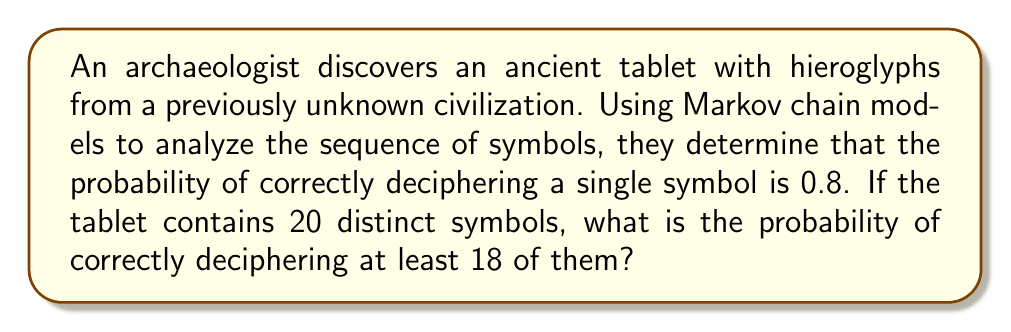Solve this math problem. Let's approach this step-by-step:

1) This problem follows a binomial distribution, where:
   n = 20 (total number of symbols)
   p = 0.8 (probability of success for each symbol)
   We want to find P(X ≥ 18), where X is the number of correctly deciphered symbols.

2) We can calculate this as:
   P(X ≥ 18) = P(X = 18) + P(X = 19) + P(X = 20)

3) The probability mass function for a binomial distribution is:
   $$P(X = k) = \binom{n}{k} p^k (1-p)^{n-k}$$

4) Let's calculate each probability:

   For k = 18:
   $$P(X = 18) = \binom{20}{18} (0.8)^{18} (0.2)^2 = 190 \cdot 0.8^{18} \cdot 0.2^2 = 0.2759$$

   For k = 19:
   $$P(X = 19) = \binom{20}{19} (0.8)^{19} (0.2)^1 = 20 \cdot 0.8^{19} \cdot 0.2 = 0.3932$$

   For k = 20:
   $$P(X = 20) = \binom{20}{20} (0.8)^{20} (0.2)^0 = 1 \cdot 0.8^{20} = 0.1152$$

5) Sum these probabilities:
   P(X ≥ 18) = 0.2759 + 0.3932 + 0.1152 = 0.7843

Therefore, the probability of correctly deciphering at least 18 out of 20 symbols is approximately 0.7843 or 78.43%.
Answer: 0.7843 